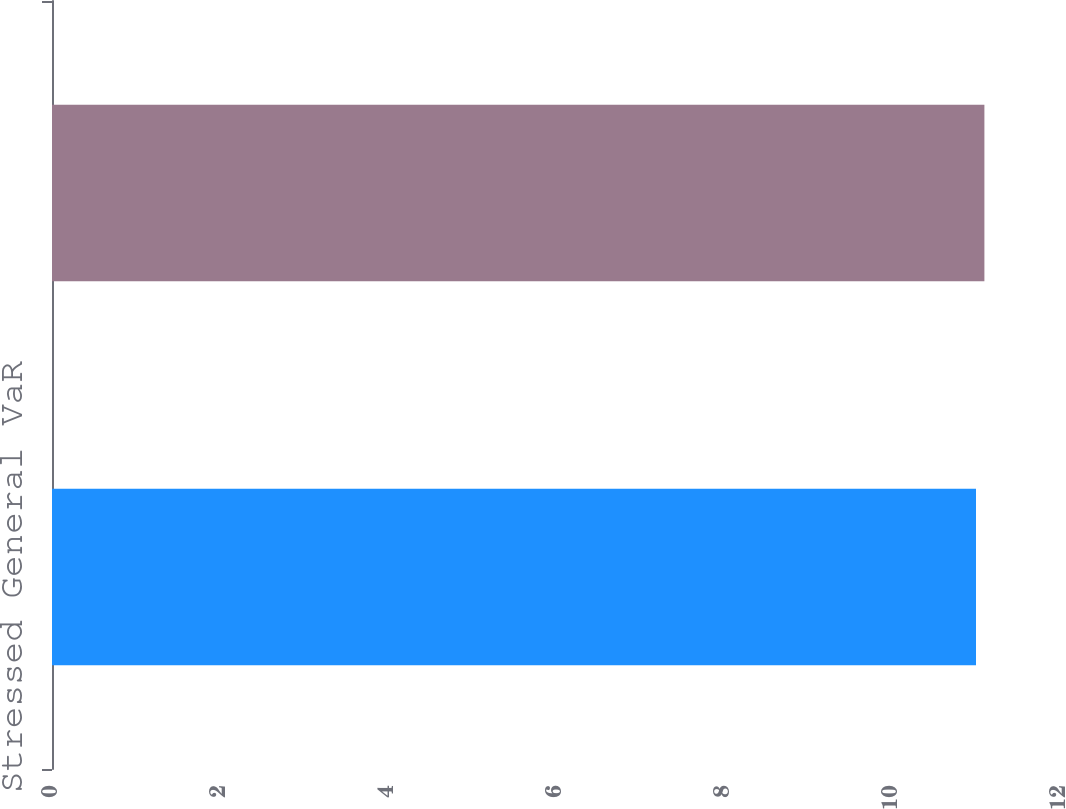Convert chart. <chart><loc_0><loc_0><loc_500><loc_500><bar_chart><fcel>Stressed General VaR<fcel>Total Stressed VaR<nl><fcel>11<fcel>11.1<nl></chart> 